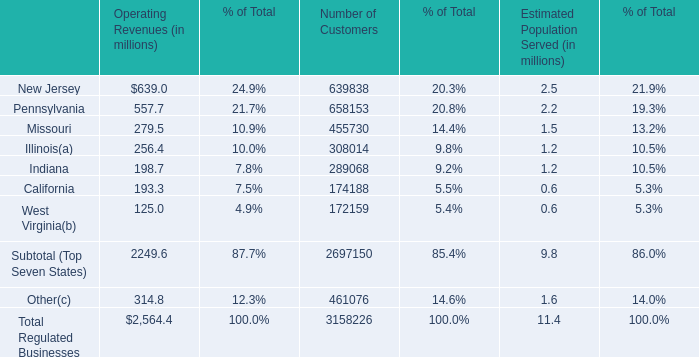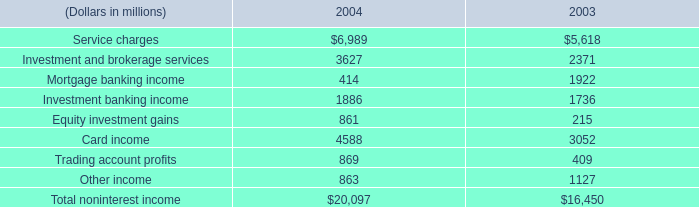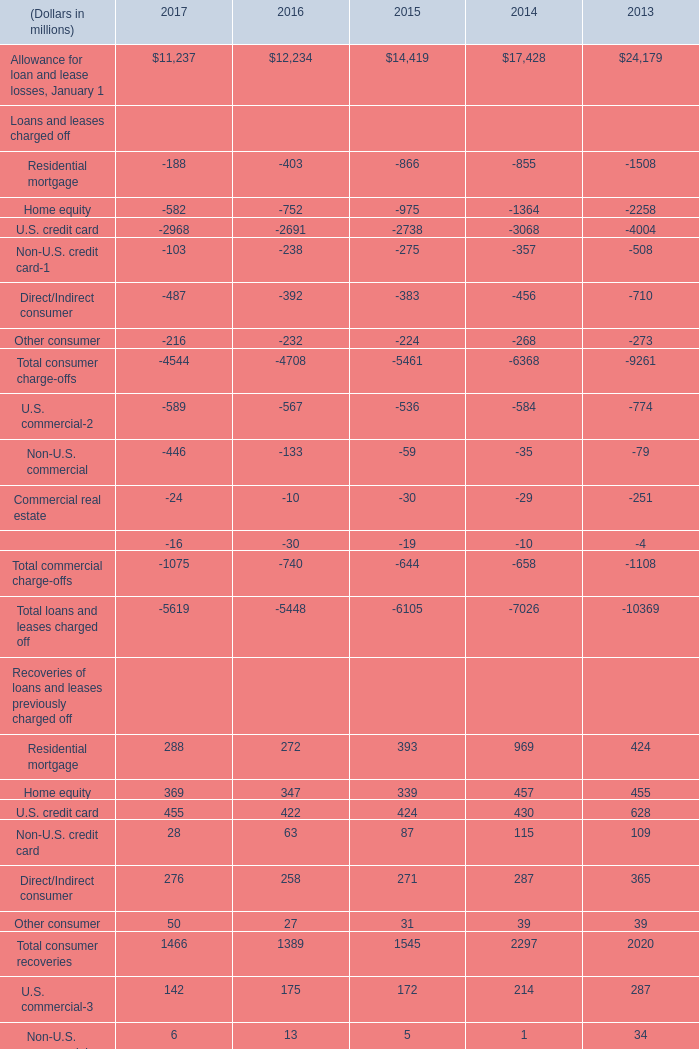In the year with largest amount of Provision for loan and lease losses in table 2, what's the sum of Total commercial recoveries in table 2? (in million) 
Answer: 238. 